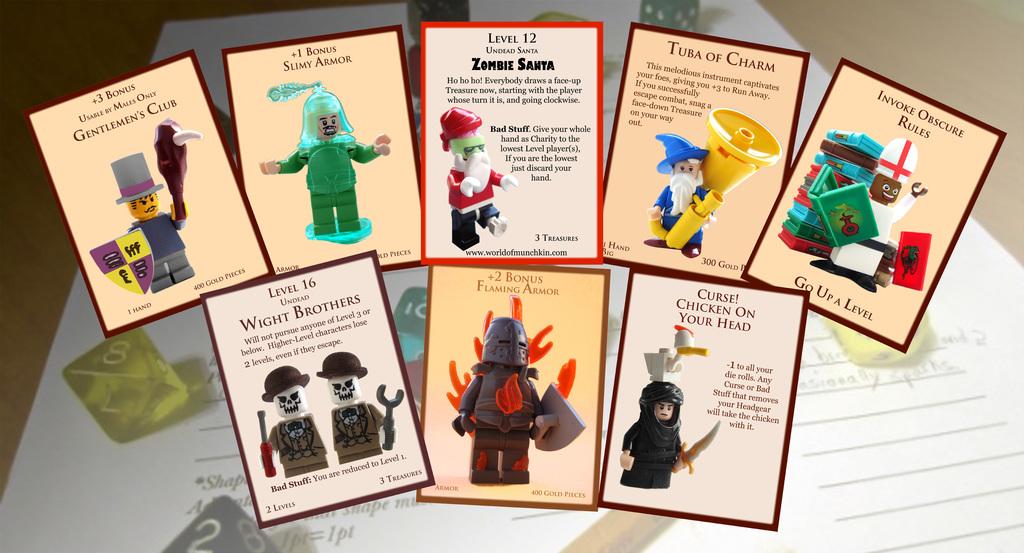What is the name of the bottom left card?
Your response must be concise. Wight brothers. 